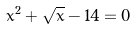<formula> <loc_0><loc_0><loc_500><loc_500>x ^ { 2 } + \sqrt { x } - 1 4 = 0</formula> 